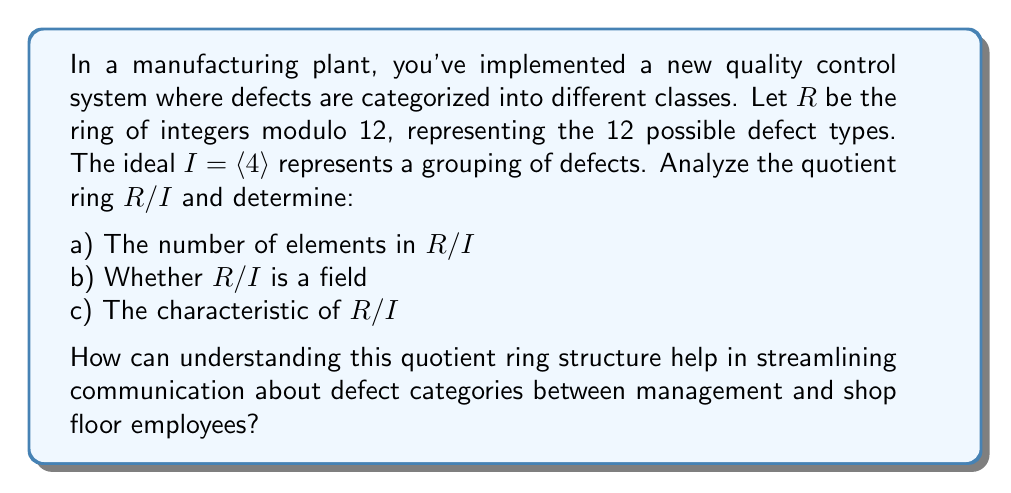Can you answer this question? Let's analyze the quotient ring $R/I$ step by step:

1) First, we need to understand what $R$ and $I$ represent:
   $R = \mathbb{Z}_{12} = \{0, 1, 2, 3, 4, 5, 6, 7, 8, 9, 10, 11\}$
   $I = \langle 4 \rangle = \{0, 4, 8\}$ (multiples of 4 in $\mathbb{Z}_{12}$)

2) The elements of $R/I$ are cosets of the form $a + I$ where $a \in R$:
   $[0] = \{0, 4, 8\}$
   $[1] = \{1, 5, 9\}$
   $[2] = \{2, 6, 10\}$
   $[3] = \{3, 7, 11\}$

a) Number of elements in $R/I$:
   There are 4 distinct cosets, so $|R/I| = 4$

b) Is $R/I$ a field?
   For $R/I$ to be a field, every non-zero element must have a multiplicative inverse.
   Let's check:
   $[1] \cdot [1] = [1]$, so $[1]$ is its own inverse
   $[2] \cdot [2] = [4] = [0]$, so $[2]$ has no inverse
   $[3] \cdot [3] = [9] = [1]$, so $[3]$ is its own inverse
   Since $[2]$ has no inverse, $R/I$ is not a field.

c) Characteristic of $R/I$:
   The characteristic is the smallest positive integer $n$ such that $n[a] = [0]$ for all $[a] \in R/I$.
   We can see that $4[1] = [4] = [0]$, and this holds for all elements.
   Therefore, the characteristic of $R/I$ is 4.

Understanding this quotient ring structure can help in communication by:
1) Simplifying the 12 defect types into 4 broader categories, making it easier to discuss and report.
2) Recognizing that some defect types are equivalent in this system, which can help in prioritizing issues.
3) The non-field nature shows that not all defect categories can be "reversed" or "fixed" in the same way, informing corrective action strategies.
4) The characteristic of 4 indicates a cyclic nature in the defect categories, which could be useful in predicting patterns or scheduling quality checks.
Answer: a) $|R/I| = 4$
b) $R/I$ is not a field
c) The characteristic of $R/I$ is 4 